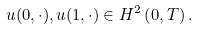Convert formula to latex. <formula><loc_0><loc_0><loc_500><loc_500>u ( 0 , \cdot ) , u ( 1 , \cdot ) \in H ^ { 2 } \left ( 0 , T \right ) .</formula> 